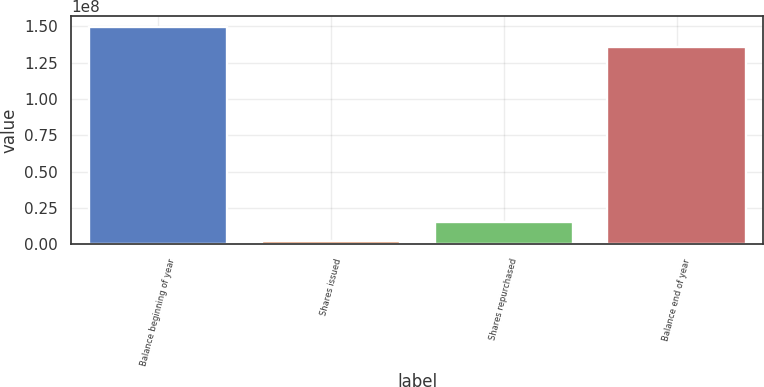<chart> <loc_0><loc_0><loc_500><loc_500><bar_chart><fcel>Balance beginning of year<fcel>Shares issued<fcel>Shares repurchased<fcel>Balance end of year<nl><fcel>1.49558e+08<fcel>2.11417e+06<fcel>1.56548e+07<fcel>1.36018e+08<nl></chart> 